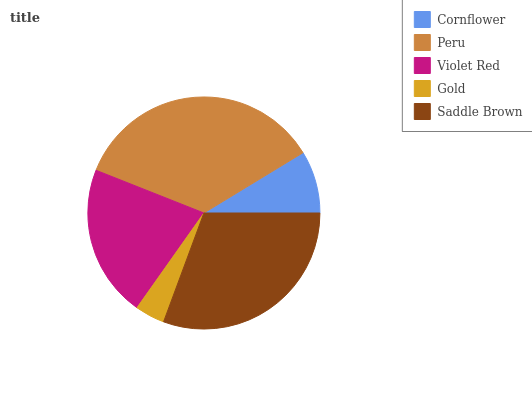Is Gold the minimum?
Answer yes or no. Yes. Is Peru the maximum?
Answer yes or no. Yes. Is Violet Red the minimum?
Answer yes or no. No. Is Violet Red the maximum?
Answer yes or no. No. Is Peru greater than Violet Red?
Answer yes or no. Yes. Is Violet Red less than Peru?
Answer yes or no. Yes. Is Violet Red greater than Peru?
Answer yes or no. No. Is Peru less than Violet Red?
Answer yes or no. No. Is Violet Red the high median?
Answer yes or no. Yes. Is Violet Red the low median?
Answer yes or no. Yes. Is Peru the high median?
Answer yes or no. No. Is Gold the low median?
Answer yes or no. No. 